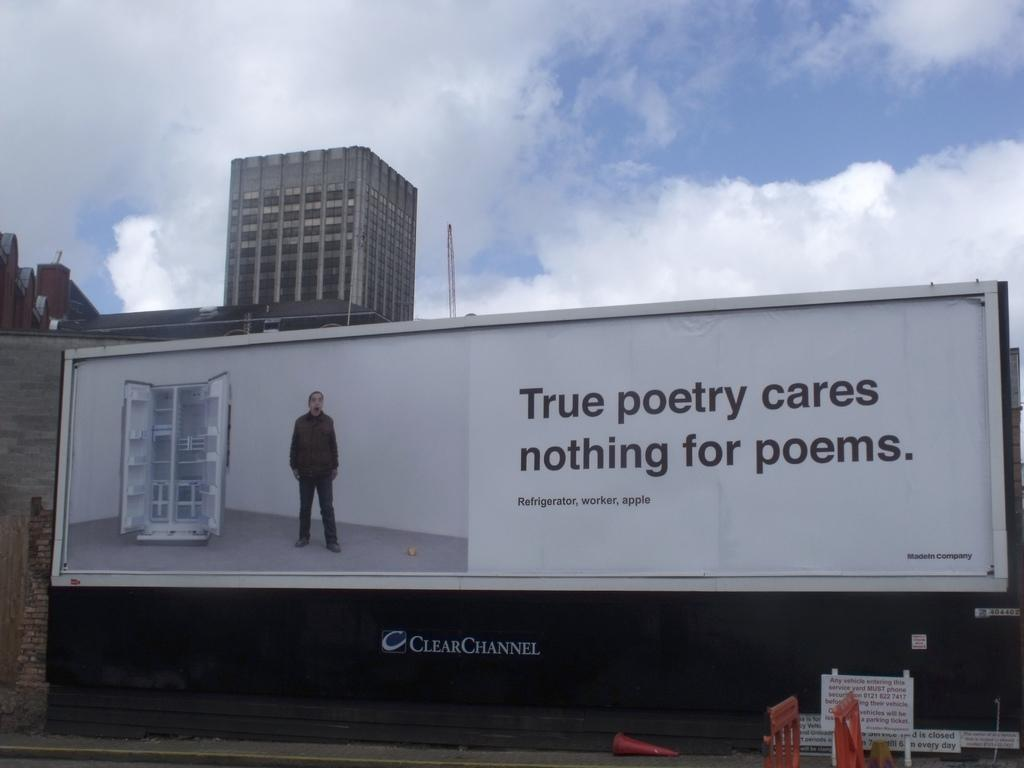Provide a one-sentence caption for the provided image. A billboard shows a man next to the phrase true poetry cares nothing for poems. 